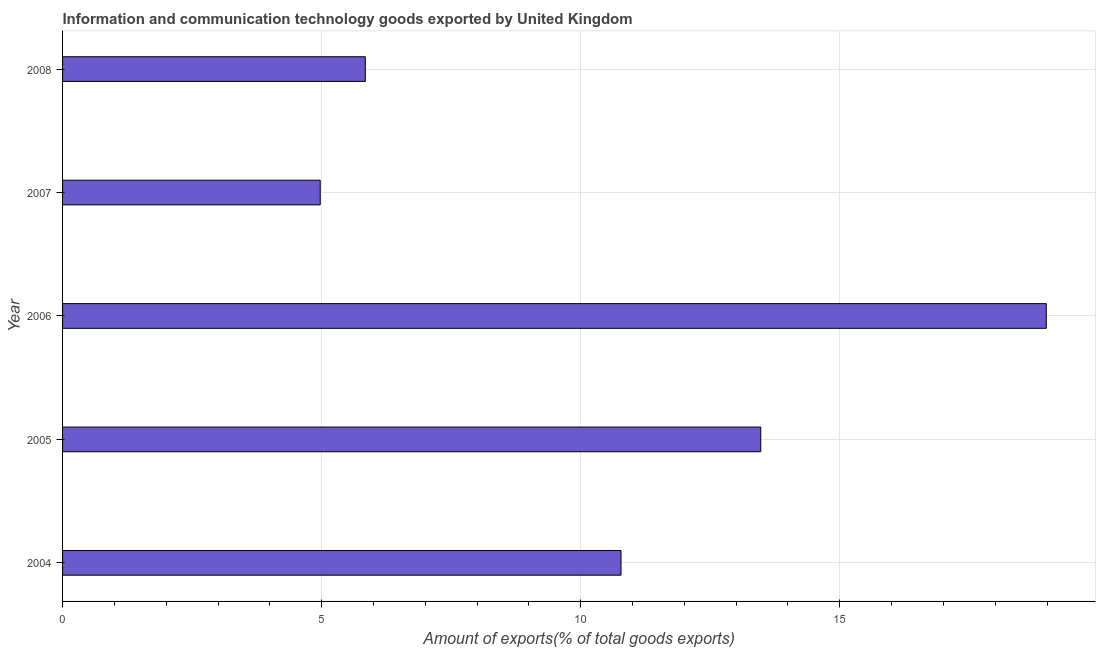Does the graph contain any zero values?
Your answer should be very brief. No. What is the title of the graph?
Give a very brief answer. Information and communication technology goods exported by United Kingdom. What is the label or title of the X-axis?
Give a very brief answer. Amount of exports(% of total goods exports). What is the amount of ict goods exports in 2006?
Keep it short and to the point. 18.99. Across all years, what is the maximum amount of ict goods exports?
Give a very brief answer. 18.99. Across all years, what is the minimum amount of ict goods exports?
Your answer should be very brief. 4.97. What is the sum of the amount of ict goods exports?
Your answer should be compact. 54.06. What is the difference between the amount of ict goods exports in 2006 and 2008?
Offer a terse response. 13.14. What is the average amount of ict goods exports per year?
Ensure brevity in your answer.  10.81. What is the median amount of ict goods exports?
Provide a short and direct response. 10.78. In how many years, is the amount of ict goods exports greater than 2 %?
Provide a short and direct response. 5. Do a majority of the years between 2006 and 2004 (inclusive) have amount of ict goods exports greater than 10 %?
Ensure brevity in your answer.  Yes. What is the ratio of the amount of ict goods exports in 2005 to that in 2007?
Provide a succinct answer. 2.71. What is the difference between the highest and the second highest amount of ict goods exports?
Keep it short and to the point. 5.51. Is the sum of the amount of ict goods exports in 2006 and 2007 greater than the maximum amount of ict goods exports across all years?
Your response must be concise. Yes. What is the difference between the highest and the lowest amount of ict goods exports?
Make the answer very short. 14.01. In how many years, is the amount of ict goods exports greater than the average amount of ict goods exports taken over all years?
Provide a short and direct response. 2. How many bars are there?
Your response must be concise. 5. Are all the bars in the graph horizontal?
Provide a succinct answer. Yes. What is the difference between two consecutive major ticks on the X-axis?
Give a very brief answer. 5. What is the Amount of exports(% of total goods exports) in 2004?
Ensure brevity in your answer.  10.78. What is the Amount of exports(% of total goods exports) in 2005?
Provide a succinct answer. 13.48. What is the Amount of exports(% of total goods exports) of 2006?
Keep it short and to the point. 18.99. What is the Amount of exports(% of total goods exports) of 2007?
Provide a short and direct response. 4.97. What is the Amount of exports(% of total goods exports) in 2008?
Give a very brief answer. 5.84. What is the difference between the Amount of exports(% of total goods exports) in 2004 and 2005?
Keep it short and to the point. -2.7. What is the difference between the Amount of exports(% of total goods exports) in 2004 and 2006?
Give a very brief answer. -8.21. What is the difference between the Amount of exports(% of total goods exports) in 2004 and 2007?
Make the answer very short. 5.81. What is the difference between the Amount of exports(% of total goods exports) in 2004 and 2008?
Provide a succinct answer. 4.93. What is the difference between the Amount of exports(% of total goods exports) in 2005 and 2006?
Provide a succinct answer. -5.51. What is the difference between the Amount of exports(% of total goods exports) in 2005 and 2007?
Provide a succinct answer. 8.5. What is the difference between the Amount of exports(% of total goods exports) in 2005 and 2008?
Make the answer very short. 7.63. What is the difference between the Amount of exports(% of total goods exports) in 2006 and 2007?
Give a very brief answer. 14.01. What is the difference between the Amount of exports(% of total goods exports) in 2006 and 2008?
Provide a short and direct response. 13.14. What is the difference between the Amount of exports(% of total goods exports) in 2007 and 2008?
Offer a terse response. -0.87. What is the ratio of the Amount of exports(% of total goods exports) in 2004 to that in 2006?
Provide a short and direct response. 0.57. What is the ratio of the Amount of exports(% of total goods exports) in 2004 to that in 2007?
Offer a terse response. 2.17. What is the ratio of the Amount of exports(% of total goods exports) in 2004 to that in 2008?
Keep it short and to the point. 1.84. What is the ratio of the Amount of exports(% of total goods exports) in 2005 to that in 2006?
Make the answer very short. 0.71. What is the ratio of the Amount of exports(% of total goods exports) in 2005 to that in 2007?
Keep it short and to the point. 2.71. What is the ratio of the Amount of exports(% of total goods exports) in 2005 to that in 2008?
Your answer should be very brief. 2.31. What is the ratio of the Amount of exports(% of total goods exports) in 2006 to that in 2007?
Ensure brevity in your answer.  3.82. What is the ratio of the Amount of exports(% of total goods exports) in 2006 to that in 2008?
Provide a succinct answer. 3.25. What is the ratio of the Amount of exports(% of total goods exports) in 2007 to that in 2008?
Provide a succinct answer. 0.85. 